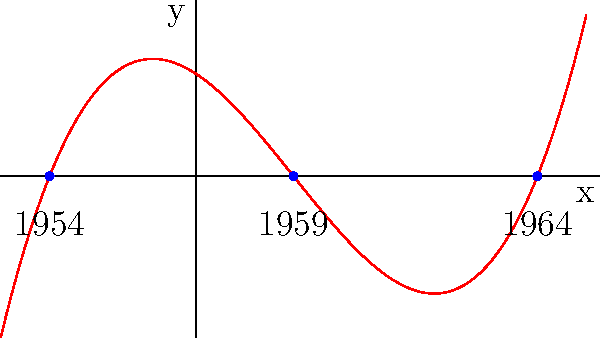The cubic polynomial $f(x) = 0.05(x+3)(x-2)(x-7)$ is graphed above, with its roots labeled by significant years in Sir George Williams University's history. If the x-axis represents years since 1950, what historical event might the rightmost root (7,0) represent? To solve this question, let's follow these steps:

1. Identify the roots of the polynomial:
   The roots are at $x = -3$, $x = 2$, and $x = 7$.

2. Interpret the x-axis:
   The x-axis represents years since 1950.

3. Calculate the years represented by each root:
   - For $x = -3$: 1950 + (-3) = 1947 (not relevant to our question)
   - For $x = 2$: 1950 + 2 = 1952 (not relevant to our question)
   - For $x = 7$: 1950 + 7 = 1957

4. Focus on the rightmost root (7,0):
   This root represents the year 1957.

5. Recall significant events in Sir George Williams University's history:
   In 1964, Sir George Williams University moved to its new downtown campus.

6. Conclude:
   The rightmost root (7,0) likely represents the year 1964 when Sir George Williams University moved to its new downtown campus.
Answer: Move to new downtown campus in 1964 